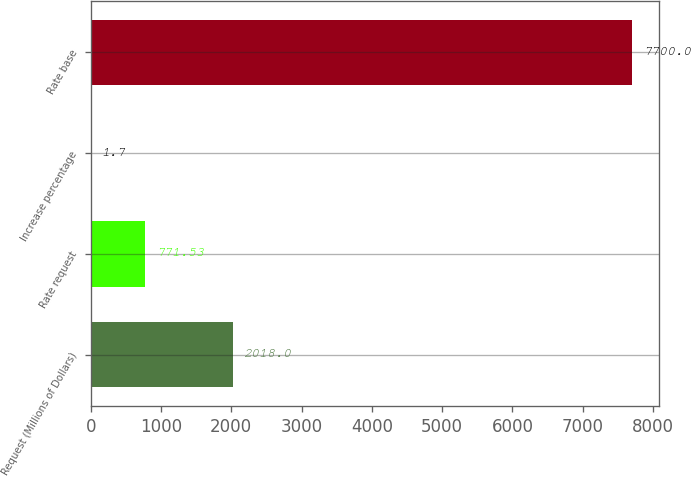Convert chart. <chart><loc_0><loc_0><loc_500><loc_500><bar_chart><fcel>Request (Millions of Dollars)<fcel>Rate request<fcel>Increase percentage<fcel>Rate base<nl><fcel>2018<fcel>771.53<fcel>1.7<fcel>7700<nl></chart> 